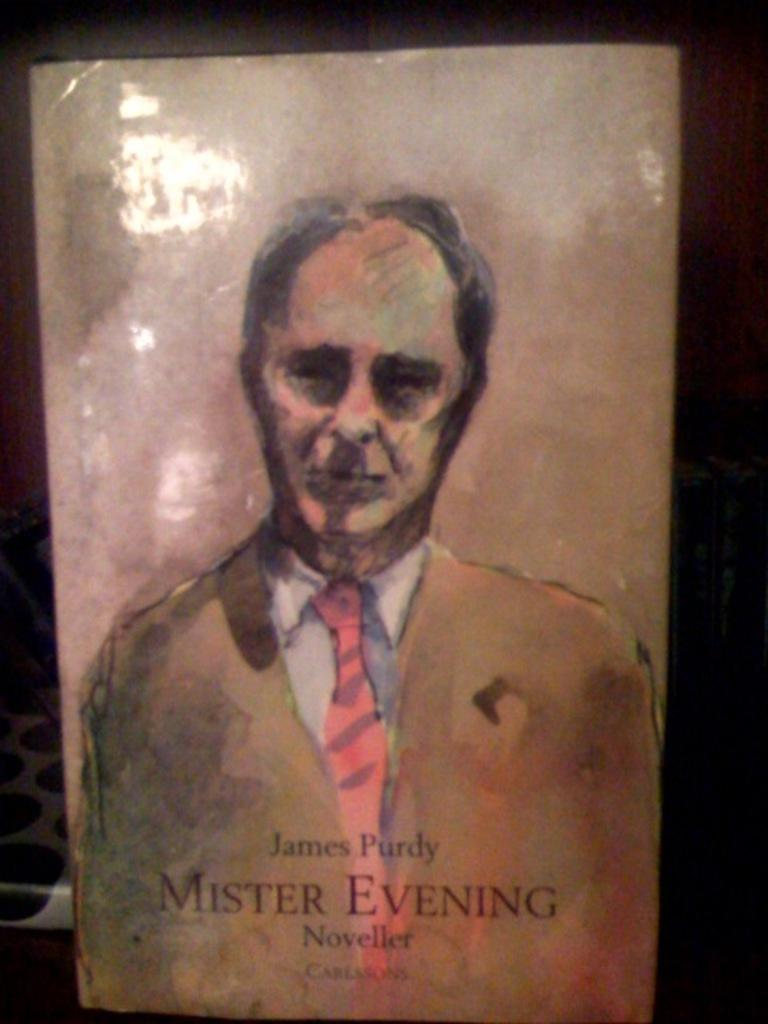What is the main subject of the image? The main subject of the image is a person's wall painting on the floor in the foreground. Where was the image taken? The image was taken in a room. What is the income of the person who created the wall painting in the image? There is no information about the person who created the wall painting or their income in the image. 